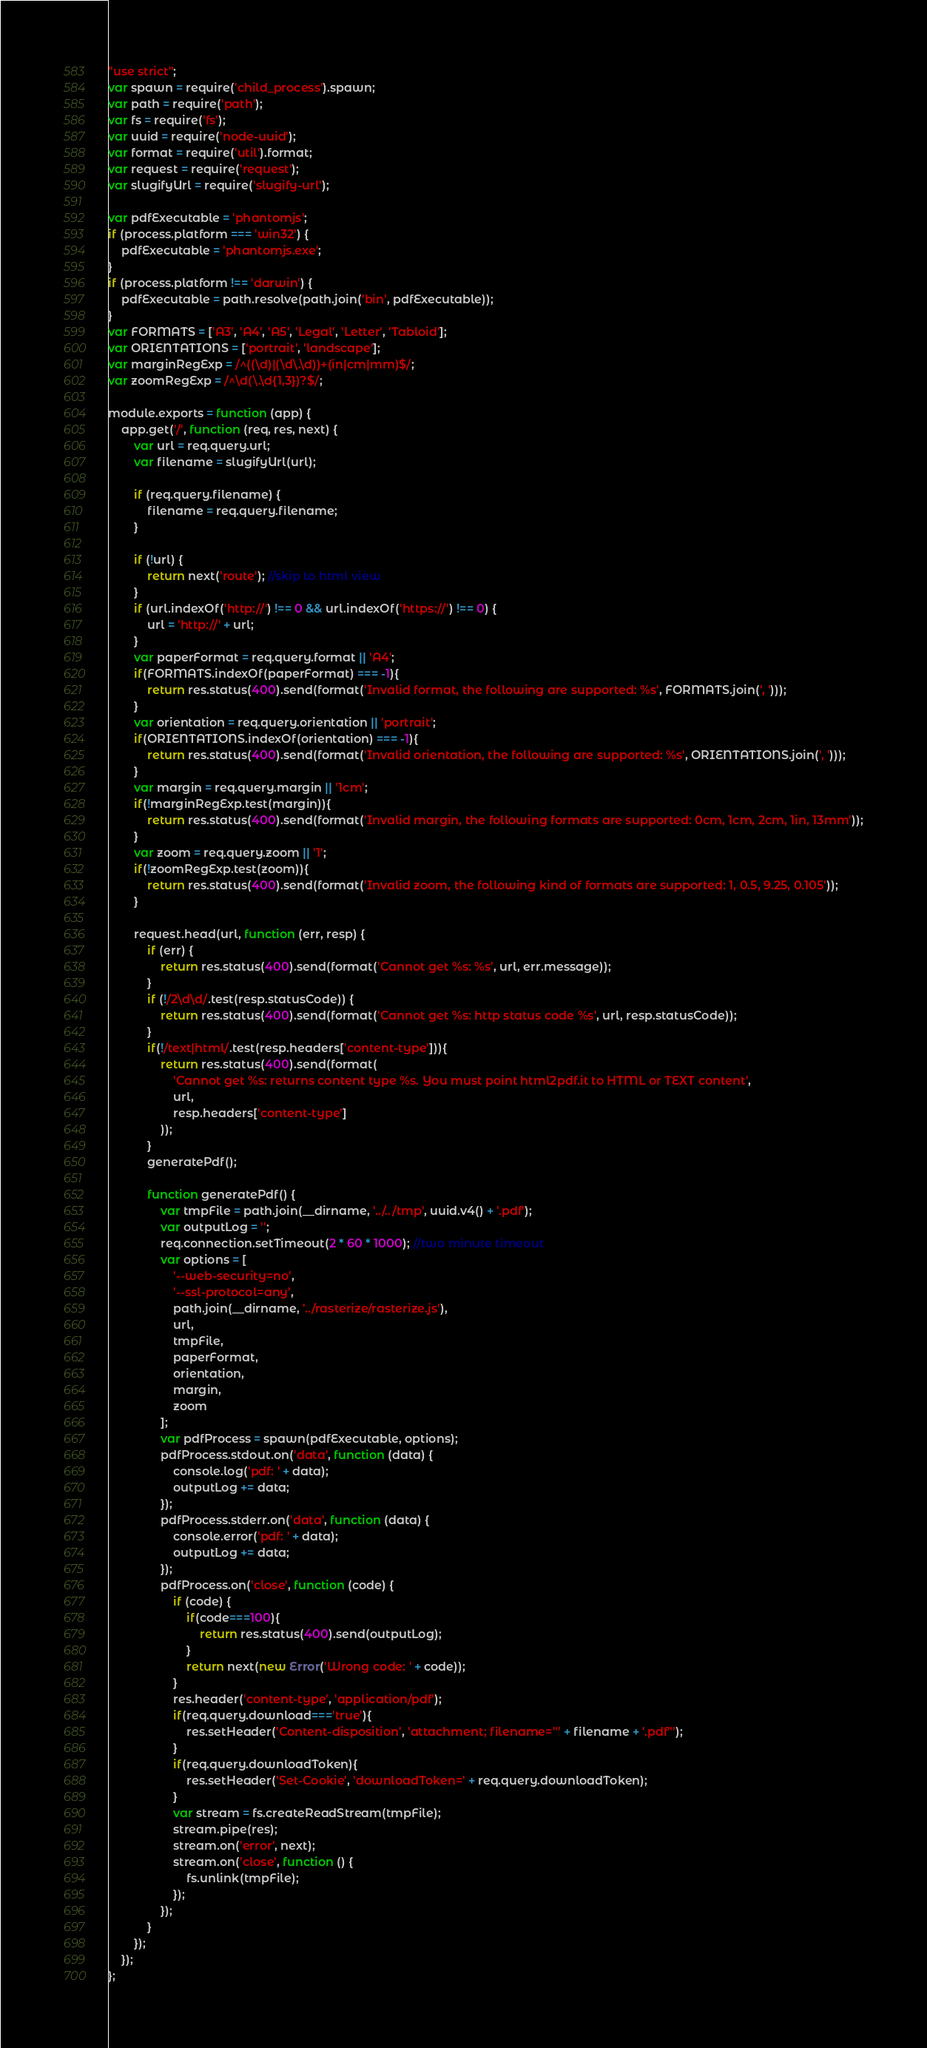<code> <loc_0><loc_0><loc_500><loc_500><_JavaScript_>"use strict";
var spawn = require('child_process').spawn;
var path = require('path');
var fs = require('fs');
var uuid = require('node-uuid');
var format = require('util').format;
var request = require('request');
var slugifyUrl = require('slugify-url');

var pdfExecutable = 'phantomjs';
if (process.platform === 'win32') {
	pdfExecutable = 'phantomjs.exe';
}
if (process.platform !== 'darwin') {
	pdfExecutable = path.resolve(path.join('bin', pdfExecutable));
}
var FORMATS = ['A3', 'A4', 'A5', 'Legal', 'Letter', 'Tabloid'];
var ORIENTATIONS = ['portrait', 'landscape'];
var marginRegExp = /^((\d)|(\d\.\d))+(in|cm|mm)$/;
var zoomRegExp = /^\d(\.\d{1,3})?$/;

module.exports = function (app) {
	app.get('/', function (req, res, next) {
		var url = req.query.url;
		var filename = slugifyUrl(url);
		
		if (req.query.filename) {
			filename = req.query.filename;
		}
		
		if (!url) {
			return next('route'); //skip to html view
		}
		if (url.indexOf('http://') !== 0 && url.indexOf('https://') !== 0) {
			url = 'http://' + url;
		}
		var paperFormat = req.query.format || 'A4';
		if(FORMATS.indexOf(paperFormat) === -1){
			return res.status(400).send(format('Invalid format, the following are supported: %s', FORMATS.join(', ')));
		}
		var orientation = req.query.orientation || 'portrait';
		if(ORIENTATIONS.indexOf(orientation) === -1){
			return res.status(400).send(format('Invalid orientation, the following are supported: %s', ORIENTATIONS.join(', ')));
		}
		var margin = req.query.margin || '1cm';
		if(!marginRegExp.test(margin)){
			return res.status(400).send(format('Invalid margin, the following formats are supported: 0cm, 1cm, 2cm, 1in, 13mm'));
		}
		var zoom = req.query.zoom || '1';
		if(!zoomRegExp.test(zoom)){
			return res.status(400).send(format('Invalid zoom, the following kind of formats are supported: 1, 0.5, 9.25, 0.105'));
		}

		request.head(url, function (err, resp) {
			if (err) {
				return res.status(400).send(format('Cannot get %s: %s', url, err.message));
			}
			if (!/2\d\d/.test(resp.statusCode)) {
				return res.status(400).send(format('Cannot get %s: http status code %s', url, resp.statusCode));
			}
			if(!/text|html/.test(resp.headers['content-type'])){
				return res.status(400).send(format(
					'Cannot get %s: returns content type %s. You must point html2pdf.it to HTML or TEXT content',
					url,
					resp.headers['content-type']
				));
			}
			generatePdf();

			function generatePdf() {
				var tmpFile = path.join(__dirname, '../../tmp', uuid.v4() + '.pdf');
				var outputLog = '';
				req.connection.setTimeout(2 * 60 * 1000); //two minute timeout
				var options = [
					'--web-security=no',
					'--ssl-protocol=any',
					path.join(__dirname, '../rasterize/rasterize.js'),
					url,
					tmpFile,
					paperFormat,
					orientation,
					margin,
					zoom
				];
				var pdfProcess = spawn(pdfExecutable, options);
				pdfProcess.stdout.on('data', function (data) {
					console.log('pdf: ' + data);
					outputLog += data;
				});
				pdfProcess.stderr.on('data', function (data) {
					console.error('pdf: ' + data);
					outputLog += data;
				});
				pdfProcess.on('close', function (code) {
					if (code) {
						if(code===100){
							return res.status(400).send(outputLog);
						}
						return next(new Error('Wrong code: ' + code));
					}
					res.header('content-type', 'application/pdf');
					if(req.query.download==='true'){
						res.setHeader('Content-disposition', 'attachment; filename="' + filename + '.pdf"');
					}
					if(req.query.downloadToken){
						res.setHeader('Set-Cookie', 'downloadToken=' + req.query.downloadToken);
					}
					var stream = fs.createReadStream(tmpFile);
					stream.pipe(res);
					stream.on('error', next);
					stream.on('close', function () {
						fs.unlink(tmpFile);
					});
				});
			}
		});
	});
};
</code> 